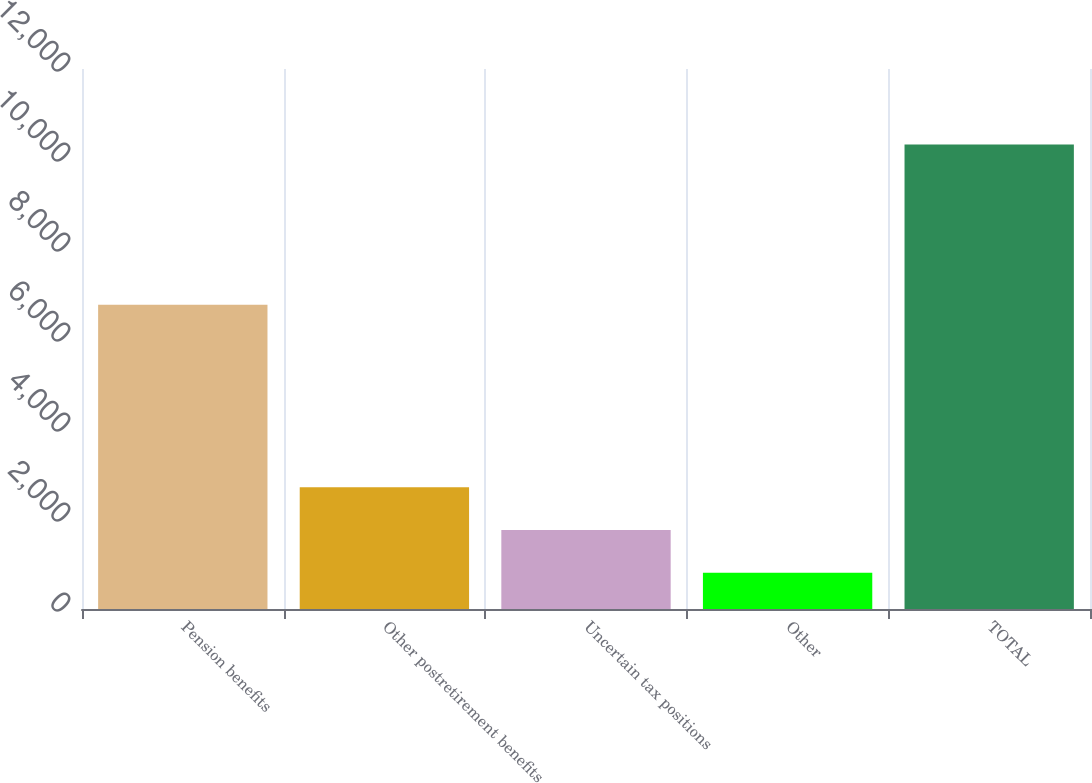<chart> <loc_0><loc_0><loc_500><loc_500><bar_chart><fcel>Pension benefits<fcel>Other postretirement benefits<fcel>Uncertain tax positions<fcel>Other<fcel>TOTAL<nl><fcel>6761<fcel>2708.2<fcel>1756.1<fcel>804<fcel>10325<nl></chart> 